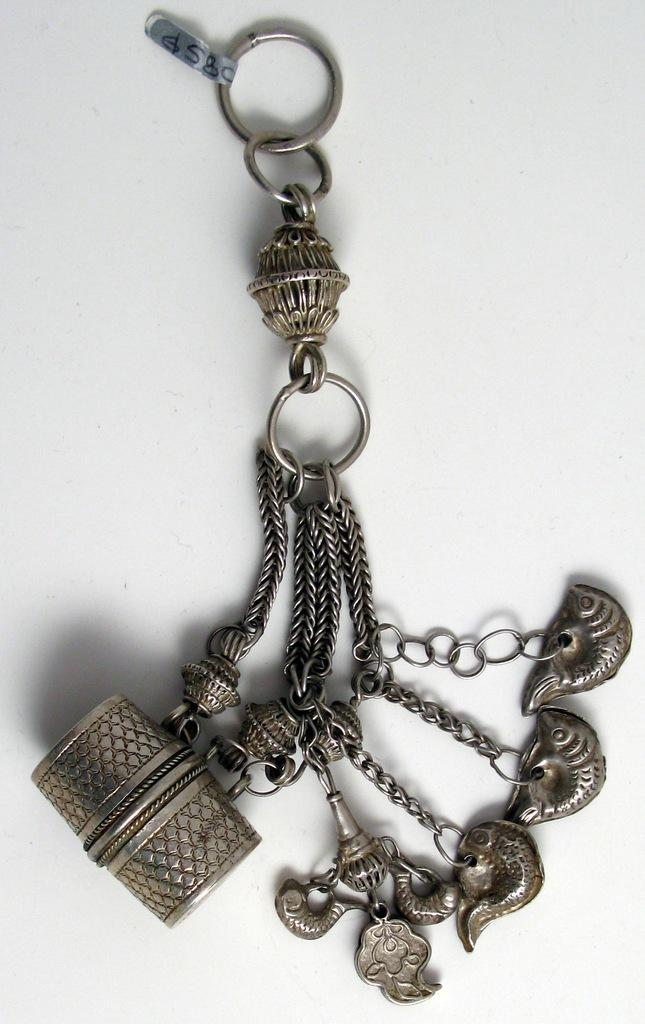What type of object is depicted in the image? The object is a keychain. What are some features of the keychain? There are rings, chains, and an artificial drum on the keychain. Are there any other items attached to the keychain? Yes, other items are linked to the keychain. Does the keychain have any form of identification? Yes, the keychain has a tag. What is the color of the background in the image? The background appears to be white in color. Can you tell me how many marks are visible on the artificial drum in the image? There are no marks visible on the artificial drum in the image; it is a solid object. Is there a neck attached to the keychain in the image? No, there is no neck attached to the keychain in the image. 